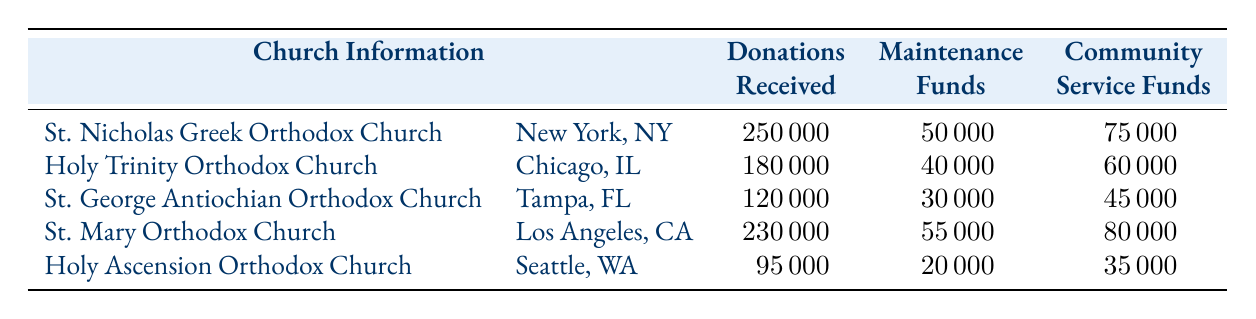What church received the highest donations? By examining the "Donations Received" column, St. Nicholas Greek Orthodox Church has the highest value of 250,000.
Answer: St. Nicholas Greek Orthodox Church What is the total community service funds received by all churches? Adding the community service funds from each church gives us: 75,000 + 60,000 + 45,000 + 80,000 + 35,000 = 295,000.
Answer: 295,000 Did Holy Trinity Orthodox Church receive more than 200,000 in donations? By checking the "Donations Received" for Holy Trinity Orthodox Church, the value is 180,000, which is less than 200,000.
Answer: No What is the average maintenance funds across all churches? The maintenance funds are 50,000, 40,000, 30,000, 55,000, and 20,000. The total is 50,000 + 40,000 + 30,000 + 55,000 + 20,000 = 195,000. Dividing by the number of churches (5) gives 195,000 / 5 = 39,000.
Answer: 39,000 Which church located in Los Angeles has more community service funds than maintenance funds? St. Mary Orthodox Church in Los Angeles has community service funds of 80,000 and maintenance funds of 55,000, showing that it has more community funds.
Answer: Yes What is the total of donations received from churches located in New York and Chicago? The donations from St. Nicholas Greek Orthodox Church (New York) is 250,000 and Holy Trinity Orthodox Church (Chicago) is 180,000. Adding these gives: 250,000 + 180,000 = 430,000.
Answer: 430,000 Is St. George Antiochian Orthodox Church's total financial contributions (donations, maintenance, community) greater than 200,000? Calculating St. George Antiochian Orthodox Church's total: 120,000 (donations) + 30,000 (maintenance) + 45,000 (community) = 195,000, which is less than 200,000.
Answer: No What is the difference in donations received between St. Mary Orthodox Church and Holy Ascension Orthodox Church? St. Mary Orthodox Church received 230,000 and Holy Ascension Orthodox Church received 95,000. The difference is 230,000 - 95,000 = 135,000.
Answer: 135,000 